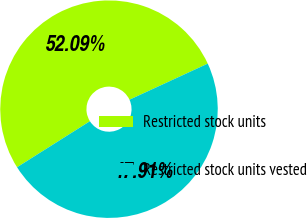Convert chart to OTSL. <chart><loc_0><loc_0><loc_500><loc_500><pie_chart><fcel>Restricted stock units<fcel>Restricted stock units vested<nl><fcel>52.09%<fcel>47.91%<nl></chart> 